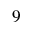<formula> <loc_0><loc_0><loc_500><loc_500>9</formula> 